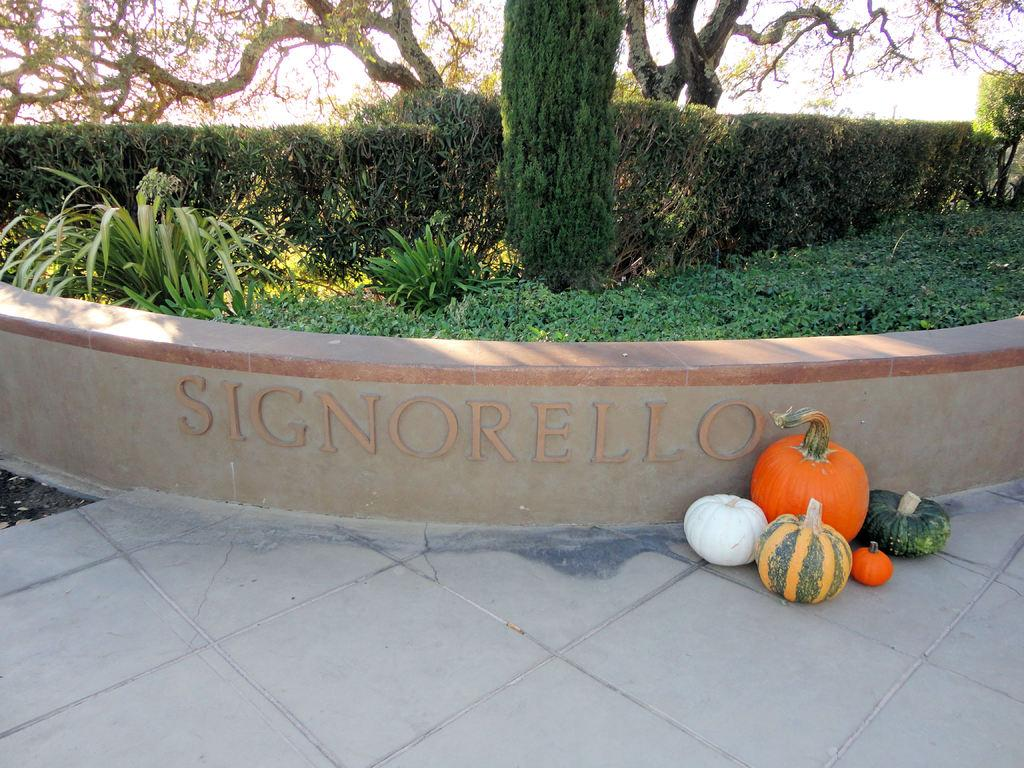What is on the floor in the image? There are vegetables on the floor in the image. What can be seen written on the wall in the image? There is text written on the wall in the image. What type of vegetation is visible in the image? There are plants and trees visible in the image. What is visible in the background of the image? The sky is visible in the background of the image. How does the cloud move in the image? There is no cloud present in the image; it only shows the sky in the background. What type of air is visible in the image? The image does not show any specific type of air; it only shows the sky in the background. 